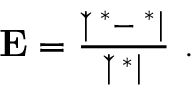Convert formula to latex. <formula><loc_0><loc_0><loc_500><loc_500>\begin{array} { r } { E = \frac { | \check { \phi } ^ { \ast } - \phi ^ { \ast } | } { | \check { \phi } ^ { \ast } | } . } \end{array}</formula> 